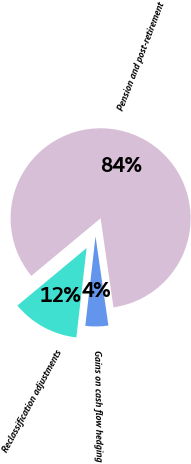Convert chart. <chart><loc_0><loc_0><loc_500><loc_500><pie_chart><fcel>Pension and post-retirement<fcel>Gains on cash flow hedging<fcel>Reclassification adjustments<nl><fcel>83.75%<fcel>4.1%<fcel>12.15%<nl></chart> 